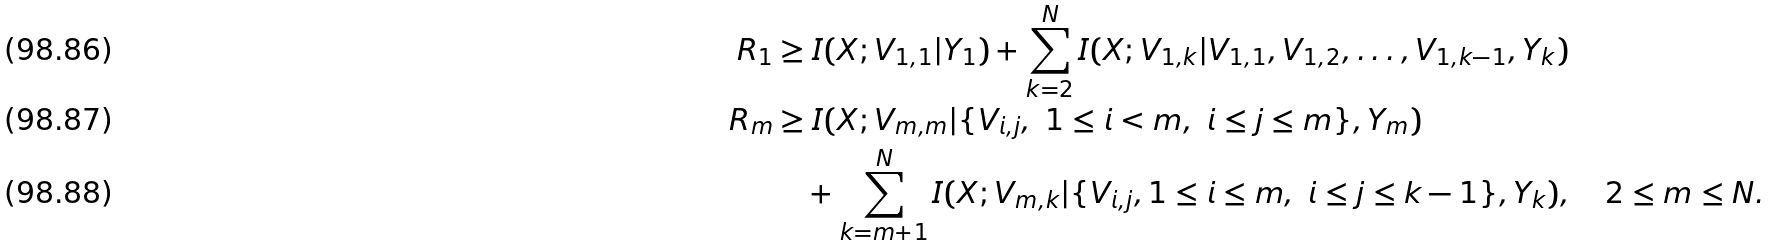Convert formula to latex. <formula><loc_0><loc_0><loc_500><loc_500>R _ { 1 } & \geq I ( X ; V _ { 1 , 1 } | Y _ { 1 } ) + \sum _ { k = 2 } ^ { N } I ( X ; V _ { 1 , k } | V _ { 1 , 1 } , V _ { 1 , 2 } , \dots , V _ { 1 , k - 1 } , Y _ { k } ) \\ R _ { m } & \geq I ( X ; V _ { m , m } | \{ V _ { i , j } , \ 1 \leq i < m , \ i \leq j \leq m \} , Y _ { m } ) \\ & \quad + \sum _ { k = m + 1 } ^ { N } I ( X ; V _ { m , k } | \{ V _ { i , j } , 1 \leq i \leq m , \ i \leq j \leq k - 1 \} , Y _ { k } ) , \quad 2 \leq m \leq N .</formula> 